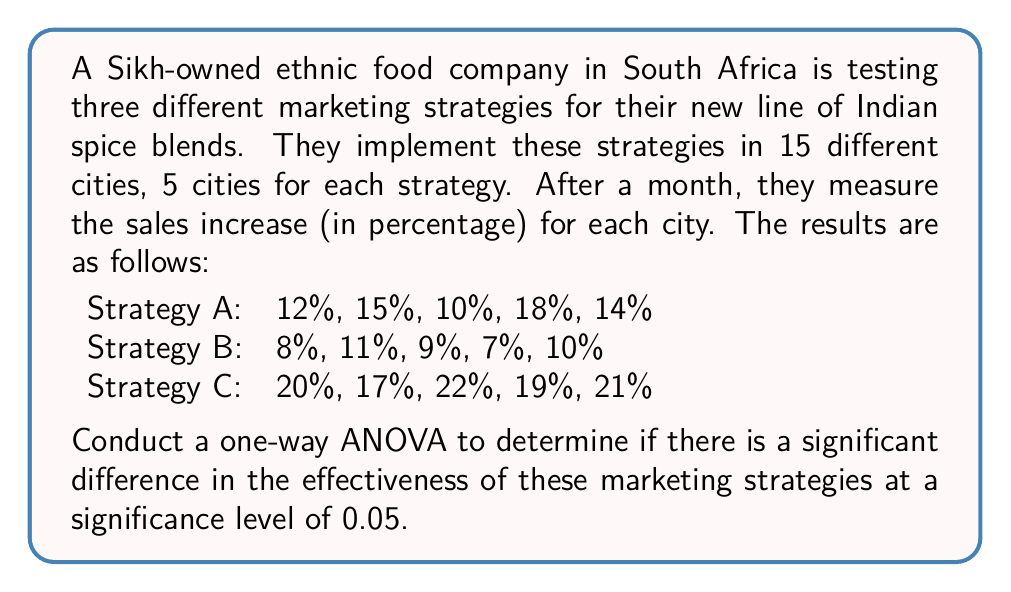Can you solve this math problem? To conduct a one-way ANOVA, we'll follow these steps:

1. Calculate the sum of squares between groups (SSB), within groups (SSW), and total (SST).
2. Calculate the degrees of freedom for between groups (dfB), within groups (dfW), and total (dfT).
3. Calculate the mean squares for between groups (MSB) and within groups (MSW).
4. Calculate the F-statistic.
5. Compare the F-statistic to the critical F-value.

Step 1: Calculate sum of squares

First, we need to calculate the grand mean:
$$ \bar{X} = \frac{213}{15} = 14.2 $$

Now, we can calculate SSB, SSW, and SST:

SSB:
$$ SSB = 5[(13.8 - 14.2)^2 + (9 - 14.2)^2 + (19.8 - 14.2)^2] = 351.6 $$

SSW:
$$ SSW = [(12-13.8)^2 + (15-13.8)^2 + (10-13.8)^2 + (18-13.8)^2 + (14-13.8)^2] + \\
[(8-9)^2 + (11-9)^2 + (9-9)^2 + (7-9)^2 + (10-9)^2] + \\
[(20-19.8)^2 + (17-19.8)^2 + (22-19.8)^2 + (19-19.8)^2 + (21-19.8)^2] = 44.8 $$

SST:
$$ SST = SSB + SSW = 351.6 + 44.8 = 396.4 $$

Step 2: Calculate degrees of freedom

$$ df_B = 3 - 1 = 2 $$
$$ df_W = 15 - 3 = 12 $$
$$ df_T = 15 - 1 = 14 $$

Step 3: Calculate mean squares

$$ MSB = \frac{SSB}{df_B} = \frac{351.6}{2} = 175.8 $$
$$ MSW = \frac{SSW}{df_W} = \frac{44.8}{12} = 3.73 $$

Step 4: Calculate F-statistic

$$ F = \frac{MSB}{MSW} = \frac{175.8}{3.73} = 47.13 $$

Step 5: Compare F-statistic to critical F-value

The critical F-value for $\alpha = 0.05$, $df_B = 2$, and $df_W = 12$ is approximately 3.89.

Since our calculated F-statistic (47.13) is greater than the critical F-value (3.89), we reject the null hypothesis.
Answer: The one-way ANOVA results show a significant difference in the effectiveness of the three marketing strategies (F(2,12) = 47.13, p < 0.05). We reject the null hypothesis and conclude that at least one marketing strategy is significantly different from the others in terms of its effectiveness in increasing sales of the Indian spice blends. 